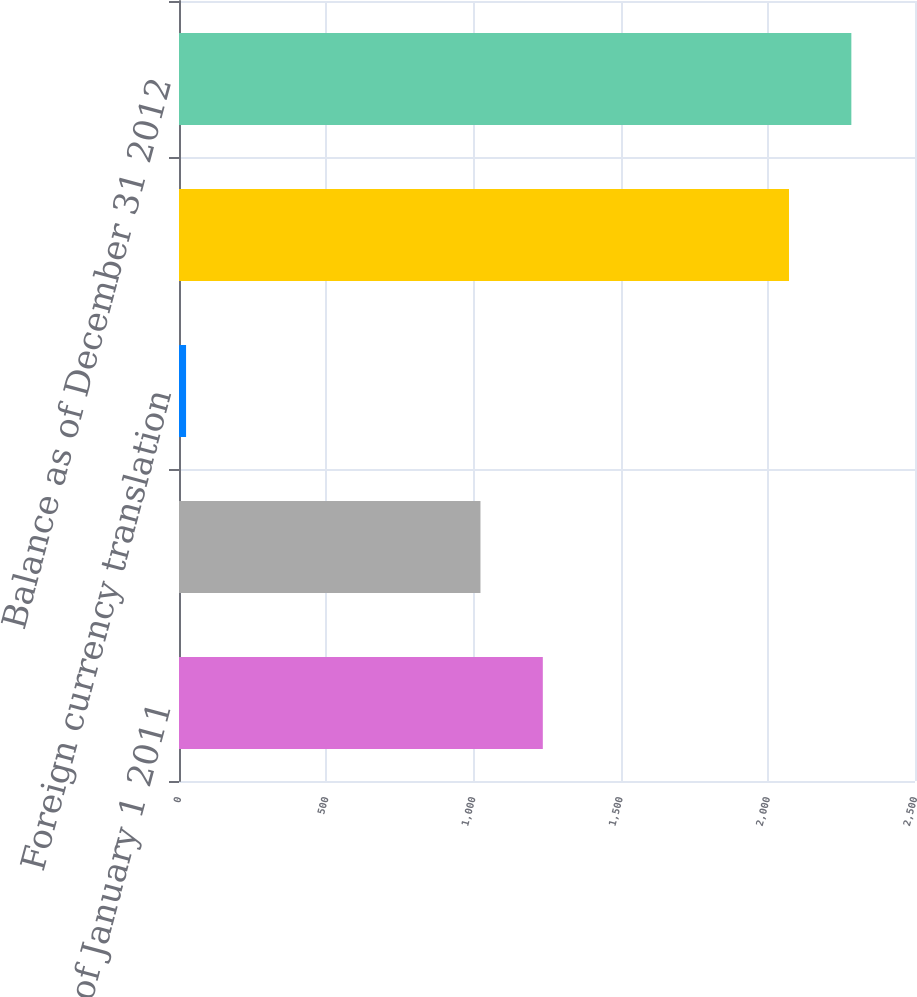<chart> <loc_0><loc_0><loc_500><loc_500><bar_chart><fcel>Balance as of January 1 2011<fcel>Goodwill acquired<fcel>Foreign currency translation<fcel>Balance as of December 31 2011<fcel>Balance as of December 31 2012<nl><fcel>1235.8<fcel>1024<fcel>24<fcel>2072<fcel>2283.8<nl></chart> 